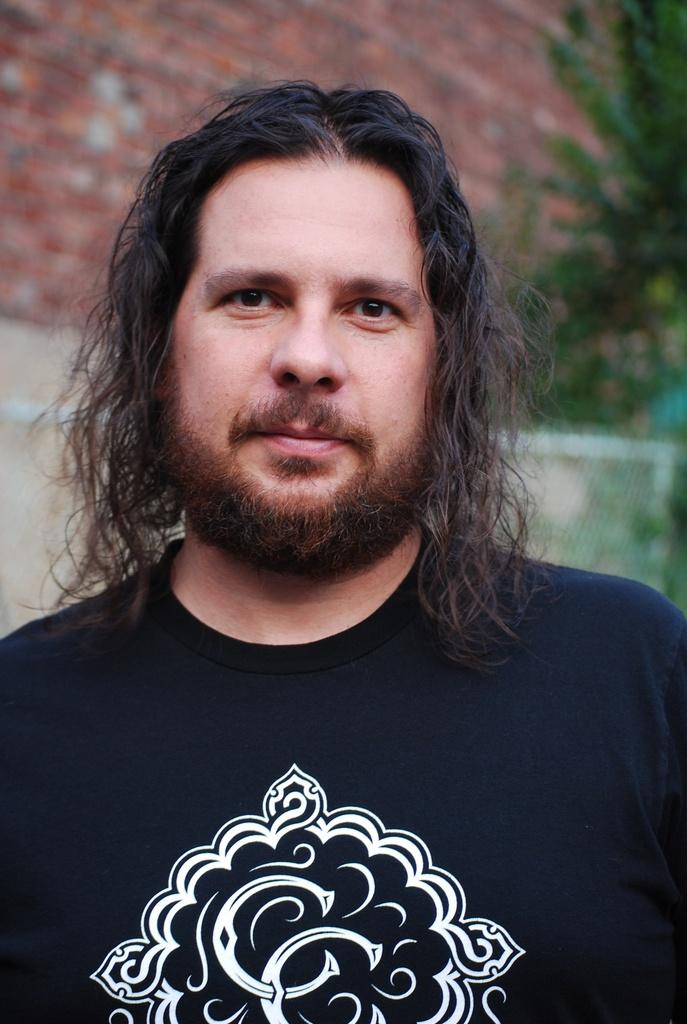Who is the main subject in the image? There is a man in the center of the image. What is the man wearing? The man is wearing a black t-shirt. What color is the wall in the background of the image? There is a red wall in the background of the image. What type of vegetation can be seen on the right side of the image? There are trees on the right side of the image. What type of brick is being used to build the collar in the image? There is no brick or collar present in the image. 